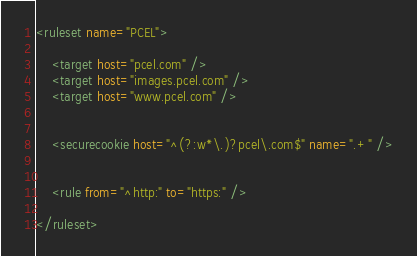<code> <loc_0><loc_0><loc_500><loc_500><_XML_><ruleset name="PCEL">

	<target host="pcel.com" />
	<target host="images.pcel.com" />
	<target host="www.pcel.com" />


	<securecookie host="^(?:w*\.)?pcel\.com$" name=".+" />


	<rule from="^http:" to="https:" />

</ruleset></code> 